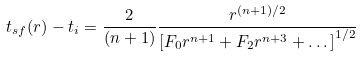<formula> <loc_0><loc_0><loc_500><loc_500>t _ { s f } ( r ) - t _ { i } = \frac { 2 } { ( n + 1 ) } \frac { r ^ { ( n + 1 ) / 2 } } { \left [ F _ { 0 } r ^ { n + 1 } + F _ { 2 } r ^ { n + 3 } + \dots \right ] ^ { 1 / 2 } }</formula> 